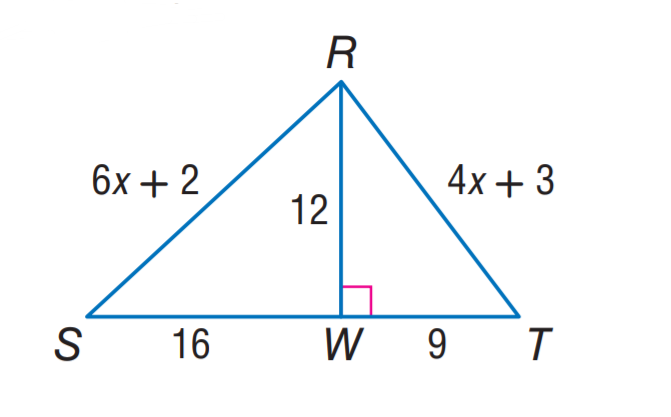Question: Find R T.
Choices:
A. 12
B. 15
C. 16
D. 20
Answer with the letter. Answer: B Question: Find R S.
Choices:
A. 15
B. 16
C. 20
D. 25
Answer with the letter. Answer: C 